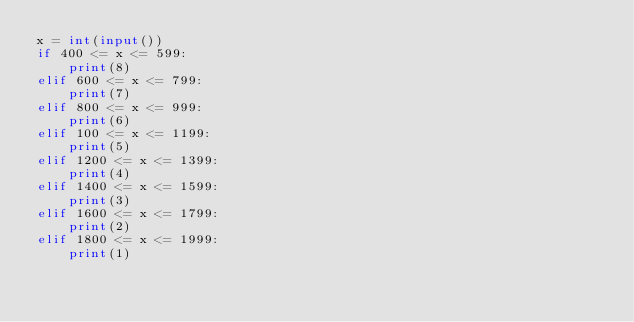Convert code to text. <code><loc_0><loc_0><loc_500><loc_500><_Python_>x = int(input())
if 400 <= x <= 599:
    print(8)
elif 600 <= x <= 799:
    print(7)
elif 800 <= x <= 999:
    print(6)
elif 100 <= x <= 1199:
    print(5)
elif 1200 <= x <= 1399:
    print(4)
elif 1400 <= x <= 1599:
    print(3)
elif 1600 <= x <= 1799:
    print(2)
elif 1800 <= x <= 1999:
    print(1)</code> 